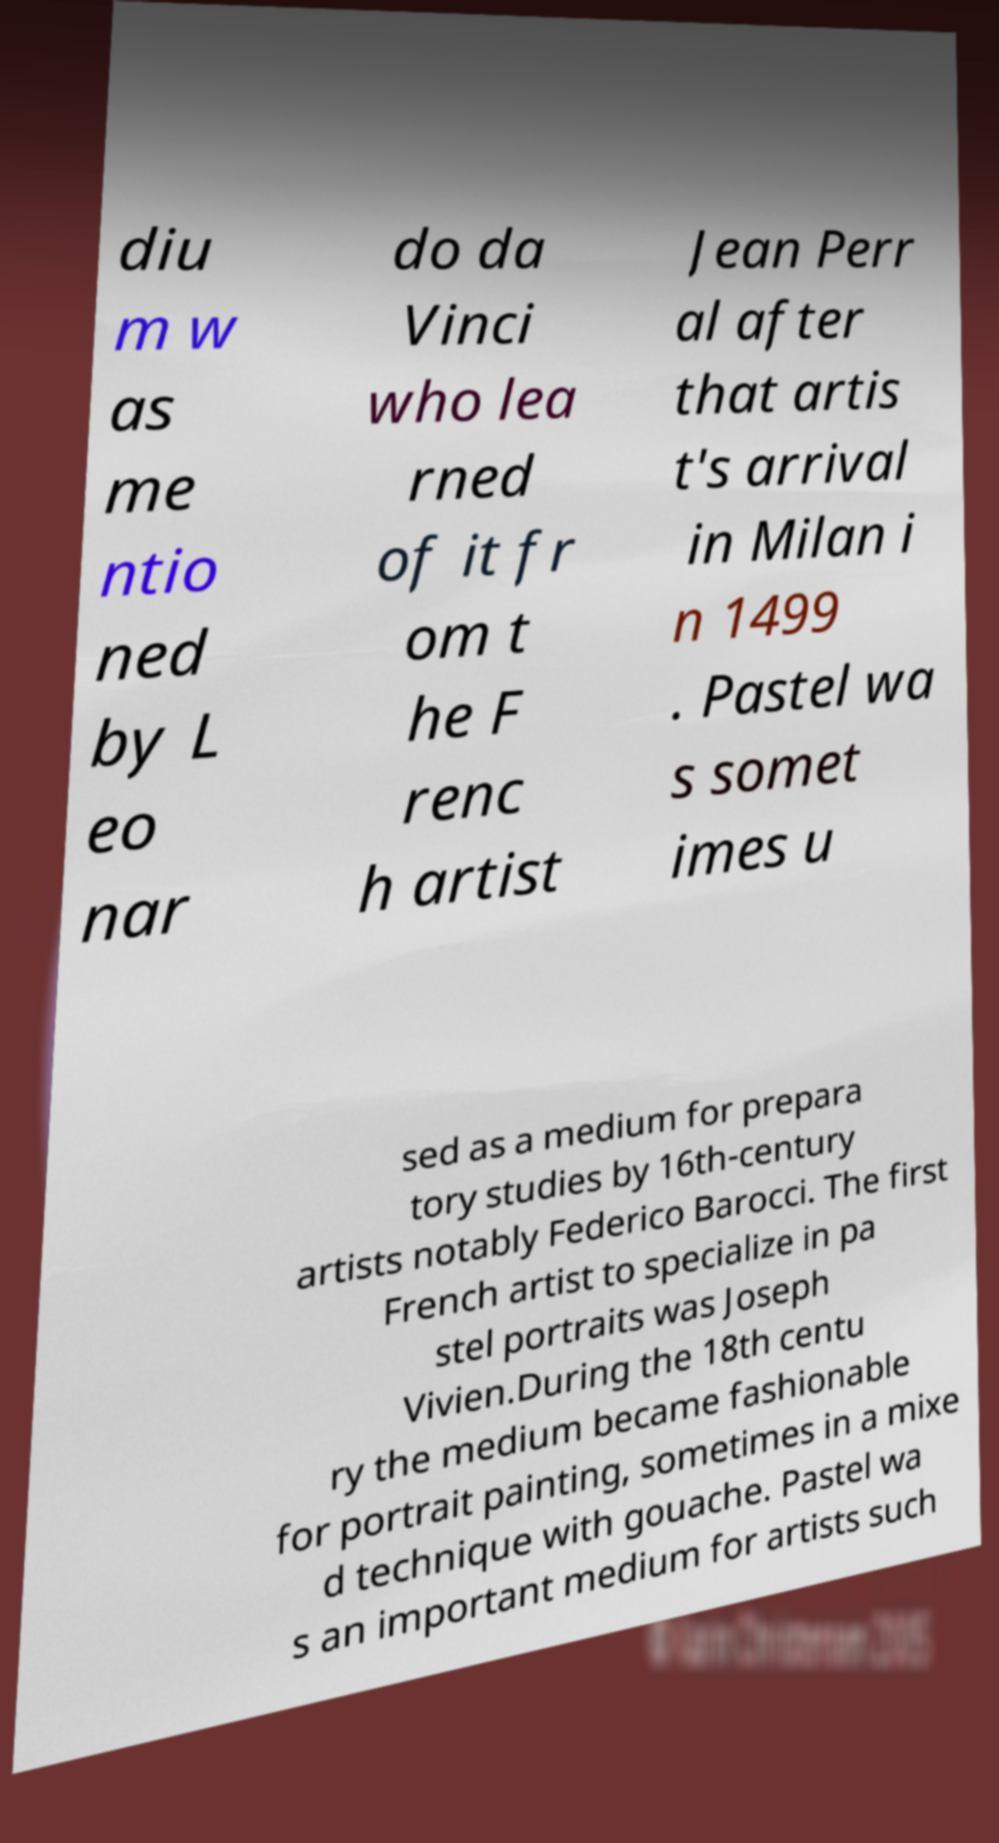For documentation purposes, I need the text within this image transcribed. Could you provide that? diu m w as me ntio ned by L eo nar do da Vinci who lea rned of it fr om t he F renc h artist Jean Perr al after that artis t's arrival in Milan i n 1499 . Pastel wa s somet imes u sed as a medium for prepara tory studies by 16th-century artists notably Federico Barocci. The first French artist to specialize in pa stel portraits was Joseph Vivien.During the 18th centu ry the medium became fashionable for portrait painting, sometimes in a mixe d technique with gouache. Pastel wa s an important medium for artists such 